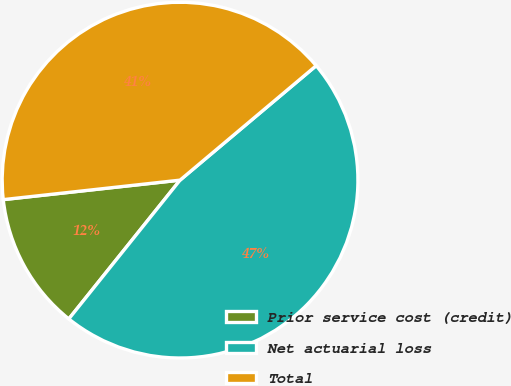Convert chart to OTSL. <chart><loc_0><loc_0><loc_500><loc_500><pie_chart><fcel>Prior service cost (credit)<fcel>Net actuarial loss<fcel>Total<nl><fcel>12.5%<fcel>46.88%<fcel>40.62%<nl></chart> 